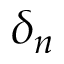<formula> <loc_0><loc_0><loc_500><loc_500>\delta _ { n }</formula> 